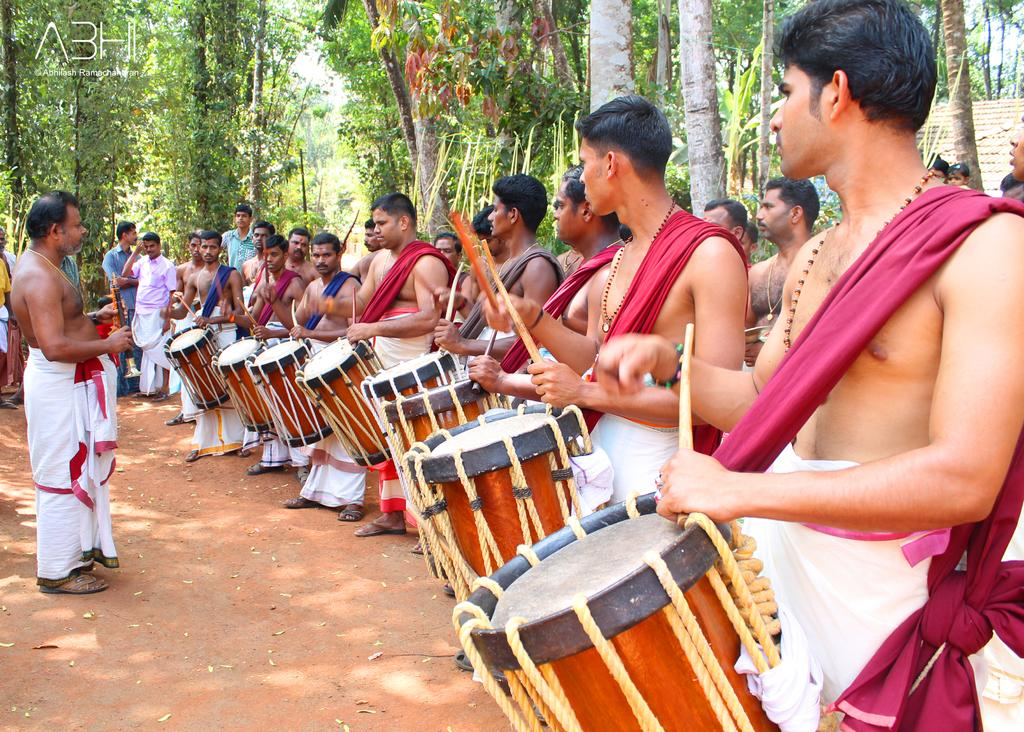What are the men in the image doing? The men in the image are beating drums. Can you describe the position of the man on the left side of the image? The man on the left side is standing. What is the man on the left side wearing? The man on the left side is wearing a white cloth. Can you tell me how many cannons are present in the image? There are no cannons present in the image; it features men beating drums. What type of tiger can be seen interacting with the man on the left side of the image? There is no tiger present in the image; the man on the left side is wearing a white cloth and standing. 